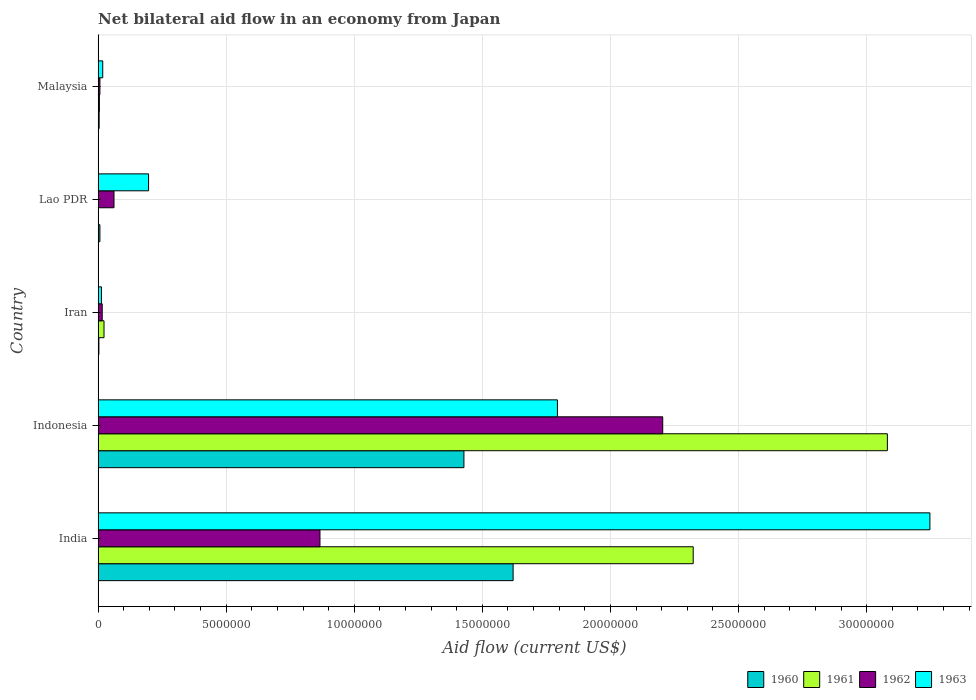Are the number of bars per tick equal to the number of legend labels?
Your answer should be compact. Yes. What is the label of the 5th group of bars from the top?
Your answer should be very brief. India. In how many cases, is the number of bars for a given country not equal to the number of legend labels?
Your answer should be very brief. 0. What is the net bilateral aid flow in 1963 in Lao PDR?
Offer a very short reply. 1.97e+06. Across all countries, what is the maximum net bilateral aid flow in 1963?
Offer a terse response. 3.25e+07. Across all countries, what is the minimum net bilateral aid flow in 1962?
Your answer should be very brief. 7.00e+04. In which country was the net bilateral aid flow in 1961 minimum?
Provide a succinct answer. Lao PDR. What is the total net bilateral aid flow in 1963 in the graph?
Ensure brevity in your answer.  5.27e+07. What is the difference between the net bilateral aid flow in 1961 in Malaysia and the net bilateral aid flow in 1962 in Iran?
Your response must be concise. -1.10e+05. What is the average net bilateral aid flow in 1961 per country?
Keep it short and to the point. 1.09e+07. What is the difference between the net bilateral aid flow in 1962 and net bilateral aid flow in 1961 in Indonesia?
Provide a succinct answer. -8.77e+06. In how many countries, is the net bilateral aid flow in 1961 greater than 5000000 US$?
Give a very brief answer. 2. What is the ratio of the net bilateral aid flow in 1963 in India to that in Indonesia?
Offer a very short reply. 1.81. Is the net bilateral aid flow in 1961 in Iran less than that in Lao PDR?
Provide a succinct answer. No. What is the difference between the highest and the second highest net bilateral aid flow in 1960?
Your answer should be very brief. 1.92e+06. What is the difference between the highest and the lowest net bilateral aid flow in 1961?
Offer a terse response. 3.08e+07. In how many countries, is the net bilateral aid flow in 1962 greater than the average net bilateral aid flow in 1962 taken over all countries?
Offer a terse response. 2. Is the sum of the net bilateral aid flow in 1963 in India and Indonesia greater than the maximum net bilateral aid flow in 1961 across all countries?
Ensure brevity in your answer.  Yes. Is it the case that in every country, the sum of the net bilateral aid flow in 1961 and net bilateral aid flow in 1960 is greater than the sum of net bilateral aid flow in 1962 and net bilateral aid flow in 1963?
Offer a terse response. No. What does the 2nd bar from the top in Malaysia represents?
Your answer should be very brief. 1962. What does the 4th bar from the bottom in Lao PDR represents?
Offer a very short reply. 1963. Is it the case that in every country, the sum of the net bilateral aid flow in 1962 and net bilateral aid flow in 1961 is greater than the net bilateral aid flow in 1963?
Make the answer very short. No. How many bars are there?
Your answer should be very brief. 20. How many countries are there in the graph?
Keep it short and to the point. 5. Are the values on the major ticks of X-axis written in scientific E-notation?
Give a very brief answer. No. How many legend labels are there?
Your answer should be very brief. 4. What is the title of the graph?
Your answer should be compact. Net bilateral aid flow in an economy from Japan. What is the label or title of the Y-axis?
Your answer should be very brief. Country. What is the Aid flow (current US$) of 1960 in India?
Give a very brief answer. 1.62e+07. What is the Aid flow (current US$) of 1961 in India?
Provide a short and direct response. 2.32e+07. What is the Aid flow (current US$) in 1962 in India?
Provide a succinct answer. 8.66e+06. What is the Aid flow (current US$) in 1963 in India?
Make the answer very short. 3.25e+07. What is the Aid flow (current US$) in 1960 in Indonesia?
Make the answer very short. 1.43e+07. What is the Aid flow (current US$) of 1961 in Indonesia?
Make the answer very short. 3.08e+07. What is the Aid flow (current US$) of 1962 in Indonesia?
Provide a short and direct response. 2.20e+07. What is the Aid flow (current US$) in 1963 in Indonesia?
Offer a terse response. 1.79e+07. What is the Aid flow (current US$) of 1960 in Iran?
Make the answer very short. 3.00e+04. What is the Aid flow (current US$) in 1961 in Iran?
Offer a terse response. 2.30e+05. What is the Aid flow (current US$) of 1962 in Iran?
Your response must be concise. 1.60e+05. What is the Aid flow (current US$) in 1960 in Lao PDR?
Provide a succinct answer. 7.00e+04. What is the Aid flow (current US$) in 1961 in Lao PDR?
Your response must be concise. 10000. What is the Aid flow (current US$) in 1962 in Lao PDR?
Offer a very short reply. 6.20e+05. What is the Aid flow (current US$) of 1963 in Lao PDR?
Provide a succinct answer. 1.97e+06. Across all countries, what is the maximum Aid flow (current US$) in 1960?
Your response must be concise. 1.62e+07. Across all countries, what is the maximum Aid flow (current US$) of 1961?
Give a very brief answer. 3.08e+07. Across all countries, what is the maximum Aid flow (current US$) of 1962?
Your answer should be compact. 2.20e+07. Across all countries, what is the maximum Aid flow (current US$) of 1963?
Your response must be concise. 3.25e+07. Across all countries, what is the minimum Aid flow (current US$) of 1960?
Provide a succinct answer. 3.00e+04. Across all countries, what is the minimum Aid flow (current US$) of 1961?
Your answer should be compact. 10000. What is the total Aid flow (current US$) of 1960 in the graph?
Make the answer very short. 3.06e+07. What is the total Aid flow (current US$) in 1961 in the graph?
Make the answer very short. 5.43e+07. What is the total Aid flow (current US$) of 1962 in the graph?
Provide a short and direct response. 3.16e+07. What is the total Aid flow (current US$) in 1963 in the graph?
Give a very brief answer. 5.27e+07. What is the difference between the Aid flow (current US$) in 1960 in India and that in Indonesia?
Provide a succinct answer. 1.92e+06. What is the difference between the Aid flow (current US$) of 1961 in India and that in Indonesia?
Your answer should be very brief. -7.58e+06. What is the difference between the Aid flow (current US$) of 1962 in India and that in Indonesia?
Your answer should be very brief. -1.34e+07. What is the difference between the Aid flow (current US$) of 1963 in India and that in Indonesia?
Make the answer very short. 1.45e+07. What is the difference between the Aid flow (current US$) in 1960 in India and that in Iran?
Ensure brevity in your answer.  1.62e+07. What is the difference between the Aid flow (current US$) of 1961 in India and that in Iran?
Give a very brief answer. 2.30e+07. What is the difference between the Aid flow (current US$) in 1962 in India and that in Iran?
Your answer should be very brief. 8.50e+06. What is the difference between the Aid flow (current US$) of 1963 in India and that in Iran?
Your answer should be very brief. 3.23e+07. What is the difference between the Aid flow (current US$) in 1960 in India and that in Lao PDR?
Offer a very short reply. 1.61e+07. What is the difference between the Aid flow (current US$) of 1961 in India and that in Lao PDR?
Your answer should be very brief. 2.32e+07. What is the difference between the Aid flow (current US$) of 1962 in India and that in Lao PDR?
Your response must be concise. 8.04e+06. What is the difference between the Aid flow (current US$) in 1963 in India and that in Lao PDR?
Your answer should be very brief. 3.05e+07. What is the difference between the Aid flow (current US$) in 1960 in India and that in Malaysia?
Offer a very short reply. 1.62e+07. What is the difference between the Aid flow (current US$) in 1961 in India and that in Malaysia?
Provide a short and direct response. 2.32e+07. What is the difference between the Aid flow (current US$) of 1962 in India and that in Malaysia?
Keep it short and to the point. 8.59e+06. What is the difference between the Aid flow (current US$) of 1963 in India and that in Malaysia?
Your answer should be very brief. 3.23e+07. What is the difference between the Aid flow (current US$) of 1960 in Indonesia and that in Iran?
Keep it short and to the point. 1.42e+07. What is the difference between the Aid flow (current US$) in 1961 in Indonesia and that in Iran?
Offer a terse response. 3.06e+07. What is the difference between the Aid flow (current US$) of 1962 in Indonesia and that in Iran?
Keep it short and to the point. 2.19e+07. What is the difference between the Aid flow (current US$) of 1963 in Indonesia and that in Iran?
Ensure brevity in your answer.  1.78e+07. What is the difference between the Aid flow (current US$) in 1960 in Indonesia and that in Lao PDR?
Provide a succinct answer. 1.42e+07. What is the difference between the Aid flow (current US$) of 1961 in Indonesia and that in Lao PDR?
Give a very brief answer. 3.08e+07. What is the difference between the Aid flow (current US$) of 1962 in Indonesia and that in Lao PDR?
Make the answer very short. 2.14e+07. What is the difference between the Aid flow (current US$) of 1963 in Indonesia and that in Lao PDR?
Provide a succinct answer. 1.60e+07. What is the difference between the Aid flow (current US$) in 1960 in Indonesia and that in Malaysia?
Make the answer very short. 1.42e+07. What is the difference between the Aid flow (current US$) of 1961 in Indonesia and that in Malaysia?
Make the answer very short. 3.08e+07. What is the difference between the Aid flow (current US$) of 1962 in Indonesia and that in Malaysia?
Give a very brief answer. 2.20e+07. What is the difference between the Aid flow (current US$) in 1963 in Indonesia and that in Malaysia?
Provide a short and direct response. 1.78e+07. What is the difference between the Aid flow (current US$) of 1960 in Iran and that in Lao PDR?
Provide a succinct answer. -4.00e+04. What is the difference between the Aid flow (current US$) of 1962 in Iran and that in Lao PDR?
Give a very brief answer. -4.60e+05. What is the difference between the Aid flow (current US$) in 1963 in Iran and that in Lao PDR?
Make the answer very short. -1.84e+06. What is the difference between the Aid flow (current US$) of 1963 in Iran and that in Malaysia?
Keep it short and to the point. -5.00e+04. What is the difference between the Aid flow (current US$) of 1960 in Lao PDR and that in Malaysia?
Ensure brevity in your answer.  3.00e+04. What is the difference between the Aid flow (current US$) in 1963 in Lao PDR and that in Malaysia?
Offer a terse response. 1.79e+06. What is the difference between the Aid flow (current US$) in 1960 in India and the Aid flow (current US$) in 1961 in Indonesia?
Your response must be concise. -1.46e+07. What is the difference between the Aid flow (current US$) in 1960 in India and the Aid flow (current US$) in 1962 in Indonesia?
Your answer should be compact. -5.84e+06. What is the difference between the Aid flow (current US$) in 1960 in India and the Aid flow (current US$) in 1963 in Indonesia?
Your answer should be very brief. -1.73e+06. What is the difference between the Aid flow (current US$) of 1961 in India and the Aid flow (current US$) of 1962 in Indonesia?
Offer a terse response. 1.19e+06. What is the difference between the Aid flow (current US$) of 1961 in India and the Aid flow (current US$) of 1963 in Indonesia?
Make the answer very short. 5.30e+06. What is the difference between the Aid flow (current US$) of 1962 in India and the Aid flow (current US$) of 1963 in Indonesia?
Your response must be concise. -9.27e+06. What is the difference between the Aid flow (current US$) in 1960 in India and the Aid flow (current US$) in 1961 in Iran?
Ensure brevity in your answer.  1.60e+07. What is the difference between the Aid flow (current US$) in 1960 in India and the Aid flow (current US$) in 1962 in Iran?
Ensure brevity in your answer.  1.60e+07. What is the difference between the Aid flow (current US$) of 1960 in India and the Aid flow (current US$) of 1963 in Iran?
Provide a short and direct response. 1.61e+07. What is the difference between the Aid flow (current US$) of 1961 in India and the Aid flow (current US$) of 1962 in Iran?
Offer a very short reply. 2.31e+07. What is the difference between the Aid flow (current US$) in 1961 in India and the Aid flow (current US$) in 1963 in Iran?
Keep it short and to the point. 2.31e+07. What is the difference between the Aid flow (current US$) in 1962 in India and the Aid flow (current US$) in 1963 in Iran?
Give a very brief answer. 8.53e+06. What is the difference between the Aid flow (current US$) of 1960 in India and the Aid flow (current US$) of 1961 in Lao PDR?
Ensure brevity in your answer.  1.62e+07. What is the difference between the Aid flow (current US$) of 1960 in India and the Aid flow (current US$) of 1962 in Lao PDR?
Your response must be concise. 1.56e+07. What is the difference between the Aid flow (current US$) of 1960 in India and the Aid flow (current US$) of 1963 in Lao PDR?
Your response must be concise. 1.42e+07. What is the difference between the Aid flow (current US$) of 1961 in India and the Aid flow (current US$) of 1962 in Lao PDR?
Your answer should be very brief. 2.26e+07. What is the difference between the Aid flow (current US$) in 1961 in India and the Aid flow (current US$) in 1963 in Lao PDR?
Give a very brief answer. 2.13e+07. What is the difference between the Aid flow (current US$) in 1962 in India and the Aid flow (current US$) in 1963 in Lao PDR?
Ensure brevity in your answer.  6.69e+06. What is the difference between the Aid flow (current US$) in 1960 in India and the Aid flow (current US$) in 1961 in Malaysia?
Offer a very short reply. 1.62e+07. What is the difference between the Aid flow (current US$) of 1960 in India and the Aid flow (current US$) of 1962 in Malaysia?
Give a very brief answer. 1.61e+07. What is the difference between the Aid flow (current US$) of 1960 in India and the Aid flow (current US$) of 1963 in Malaysia?
Make the answer very short. 1.60e+07. What is the difference between the Aid flow (current US$) of 1961 in India and the Aid flow (current US$) of 1962 in Malaysia?
Keep it short and to the point. 2.32e+07. What is the difference between the Aid flow (current US$) in 1961 in India and the Aid flow (current US$) in 1963 in Malaysia?
Offer a terse response. 2.30e+07. What is the difference between the Aid flow (current US$) in 1962 in India and the Aid flow (current US$) in 1963 in Malaysia?
Offer a terse response. 8.48e+06. What is the difference between the Aid flow (current US$) in 1960 in Indonesia and the Aid flow (current US$) in 1961 in Iran?
Your response must be concise. 1.40e+07. What is the difference between the Aid flow (current US$) of 1960 in Indonesia and the Aid flow (current US$) of 1962 in Iran?
Provide a succinct answer. 1.41e+07. What is the difference between the Aid flow (current US$) of 1960 in Indonesia and the Aid flow (current US$) of 1963 in Iran?
Your response must be concise. 1.42e+07. What is the difference between the Aid flow (current US$) of 1961 in Indonesia and the Aid flow (current US$) of 1962 in Iran?
Give a very brief answer. 3.06e+07. What is the difference between the Aid flow (current US$) in 1961 in Indonesia and the Aid flow (current US$) in 1963 in Iran?
Ensure brevity in your answer.  3.07e+07. What is the difference between the Aid flow (current US$) in 1962 in Indonesia and the Aid flow (current US$) in 1963 in Iran?
Provide a short and direct response. 2.19e+07. What is the difference between the Aid flow (current US$) in 1960 in Indonesia and the Aid flow (current US$) in 1961 in Lao PDR?
Provide a succinct answer. 1.43e+07. What is the difference between the Aid flow (current US$) in 1960 in Indonesia and the Aid flow (current US$) in 1962 in Lao PDR?
Your answer should be compact. 1.37e+07. What is the difference between the Aid flow (current US$) of 1960 in Indonesia and the Aid flow (current US$) of 1963 in Lao PDR?
Provide a short and direct response. 1.23e+07. What is the difference between the Aid flow (current US$) of 1961 in Indonesia and the Aid flow (current US$) of 1962 in Lao PDR?
Your response must be concise. 3.02e+07. What is the difference between the Aid flow (current US$) in 1961 in Indonesia and the Aid flow (current US$) in 1963 in Lao PDR?
Your answer should be compact. 2.88e+07. What is the difference between the Aid flow (current US$) of 1962 in Indonesia and the Aid flow (current US$) of 1963 in Lao PDR?
Your answer should be very brief. 2.01e+07. What is the difference between the Aid flow (current US$) in 1960 in Indonesia and the Aid flow (current US$) in 1961 in Malaysia?
Offer a very short reply. 1.42e+07. What is the difference between the Aid flow (current US$) in 1960 in Indonesia and the Aid flow (current US$) in 1962 in Malaysia?
Your answer should be very brief. 1.42e+07. What is the difference between the Aid flow (current US$) of 1960 in Indonesia and the Aid flow (current US$) of 1963 in Malaysia?
Provide a short and direct response. 1.41e+07. What is the difference between the Aid flow (current US$) in 1961 in Indonesia and the Aid flow (current US$) in 1962 in Malaysia?
Make the answer very short. 3.07e+07. What is the difference between the Aid flow (current US$) in 1961 in Indonesia and the Aid flow (current US$) in 1963 in Malaysia?
Your answer should be compact. 3.06e+07. What is the difference between the Aid flow (current US$) in 1962 in Indonesia and the Aid flow (current US$) in 1963 in Malaysia?
Your response must be concise. 2.19e+07. What is the difference between the Aid flow (current US$) in 1960 in Iran and the Aid flow (current US$) in 1961 in Lao PDR?
Keep it short and to the point. 2.00e+04. What is the difference between the Aid flow (current US$) in 1960 in Iran and the Aid flow (current US$) in 1962 in Lao PDR?
Provide a short and direct response. -5.90e+05. What is the difference between the Aid flow (current US$) in 1960 in Iran and the Aid flow (current US$) in 1963 in Lao PDR?
Keep it short and to the point. -1.94e+06. What is the difference between the Aid flow (current US$) of 1961 in Iran and the Aid flow (current US$) of 1962 in Lao PDR?
Provide a short and direct response. -3.90e+05. What is the difference between the Aid flow (current US$) in 1961 in Iran and the Aid flow (current US$) in 1963 in Lao PDR?
Provide a succinct answer. -1.74e+06. What is the difference between the Aid flow (current US$) in 1962 in Iran and the Aid flow (current US$) in 1963 in Lao PDR?
Make the answer very short. -1.81e+06. What is the difference between the Aid flow (current US$) of 1960 in Iran and the Aid flow (current US$) of 1961 in Malaysia?
Give a very brief answer. -2.00e+04. What is the difference between the Aid flow (current US$) of 1960 in Iran and the Aid flow (current US$) of 1963 in Malaysia?
Make the answer very short. -1.50e+05. What is the difference between the Aid flow (current US$) in 1961 in Iran and the Aid flow (current US$) in 1962 in Malaysia?
Your answer should be very brief. 1.60e+05. What is the difference between the Aid flow (current US$) of 1961 in Iran and the Aid flow (current US$) of 1963 in Malaysia?
Provide a succinct answer. 5.00e+04. What is the difference between the Aid flow (current US$) of 1960 in Lao PDR and the Aid flow (current US$) of 1961 in Malaysia?
Provide a short and direct response. 2.00e+04. What is the difference between the Aid flow (current US$) of 1960 in Lao PDR and the Aid flow (current US$) of 1962 in Malaysia?
Offer a very short reply. 0. What is the difference between the Aid flow (current US$) of 1960 in Lao PDR and the Aid flow (current US$) of 1963 in Malaysia?
Offer a terse response. -1.10e+05. What is the difference between the Aid flow (current US$) of 1961 in Lao PDR and the Aid flow (current US$) of 1962 in Malaysia?
Your answer should be very brief. -6.00e+04. What is the difference between the Aid flow (current US$) in 1961 in Lao PDR and the Aid flow (current US$) in 1963 in Malaysia?
Ensure brevity in your answer.  -1.70e+05. What is the difference between the Aid flow (current US$) in 1962 in Lao PDR and the Aid flow (current US$) in 1963 in Malaysia?
Ensure brevity in your answer.  4.40e+05. What is the average Aid flow (current US$) of 1960 per country?
Ensure brevity in your answer.  6.12e+06. What is the average Aid flow (current US$) in 1961 per country?
Make the answer very short. 1.09e+07. What is the average Aid flow (current US$) in 1962 per country?
Offer a very short reply. 6.31e+06. What is the average Aid flow (current US$) in 1963 per country?
Provide a succinct answer. 1.05e+07. What is the difference between the Aid flow (current US$) in 1960 and Aid flow (current US$) in 1961 in India?
Make the answer very short. -7.03e+06. What is the difference between the Aid flow (current US$) of 1960 and Aid flow (current US$) of 1962 in India?
Make the answer very short. 7.54e+06. What is the difference between the Aid flow (current US$) in 1960 and Aid flow (current US$) in 1963 in India?
Your response must be concise. -1.63e+07. What is the difference between the Aid flow (current US$) of 1961 and Aid flow (current US$) of 1962 in India?
Ensure brevity in your answer.  1.46e+07. What is the difference between the Aid flow (current US$) of 1961 and Aid flow (current US$) of 1963 in India?
Ensure brevity in your answer.  -9.24e+06. What is the difference between the Aid flow (current US$) of 1962 and Aid flow (current US$) of 1963 in India?
Give a very brief answer. -2.38e+07. What is the difference between the Aid flow (current US$) of 1960 and Aid flow (current US$) of 1961 in Indonesia?
Keep it short and to the point. -1.65e+07. What is the difference between the Aid flow (current US$) of 1960 and Aid flow (current US$) of 1962 in Indonesia?
Offer a terse response. -7.76e+06. What is the difference between the Aid flow (current US$) in 1960 and Aid flow (current US$) in 1963 in Indonesia?
Your answer should be very brief. -3.65e+06. What is the difference between the Aid flow (current US$) in 1961 and Aid flow (current US$) in 1962 in Indonesia?
Keep it short and to the point. 8.77e+06. What is the difference between the Aid flow (current US$) of 1961 and Aid flow (current US$) of 1963 in Indonesia?
Offer a terse response. 1.29e+07. What is the difference between the Aid flow (current US$) of 1962 and Aid flow (current US$) of 1963 in Indonesia?
Your answer should be very brief. 4.11e+06. What is the difference between the Aid flow (current US$) in 1960 and Aid flow (current US$) in 1963 in Iran?
Provide a short and direct response. -1.00e+05. What is the difference between the Aid flow (current US$) of 1961 and Aid flow (current US$) of 1962 in Iran?
Offer a terse response. 7.00e+04. What is the difference between the Aid flow (current US$) in 1961 and Aid flow (current US$) in 1963 in Iran?
Your answer should be compact. 1.00e+05. What is the difference between the Aid flow (current US$) in 1960 and Aid flow (current US$) in 1961 in Lao PDR?
Provide a succinct answer. 6.00e+04. What is the difference between the Aid flow (current US$) of 1960 and Aid flow (current US$) of 1962 in Lao PDR?
Give a very brief answer. -5.50e+05. What is the difference between the Aid flow (current US$) of 1960 and Aid flow (current US$) of 1963 in Lao PDR?
Give a very brief answer. -1.90e+06. What is the difference between the Aid flow (current US$) in 1961 and Aid flow (current US$) in 1962 in Lao PDR?
Your answer should be compact. -6.10e+05. What is the difference between the Aid flow (current US$) in 1961 and Aid flow (current US$) in 1963 in Lao PDR?
Your answer should be compact. -1.96e+06. What is the difference between the Aid flow (current US$) of 1962 and Aid flow (current US$) of 1963 in Lao PDR?
Offer a very short reply. -1.35e+06. What is the difference between the Aid flow (current US$) of 1960 and Aid flow (current US$) of 1961 in Malaysia?
Provide a short and direct response. -10000. What is the difference between the Aid flow (current US$) of 1960 and Aid flow (current US$) of 1962 in Malaysia?
Keep it short and to the point. -3.00e+04. What is the difference between the Aid flow (current US$) in 1961 and Aid flow (current US$) in 1962 in Malaysia?
Offer a terse response. -2.00e+04. What is the difference between the Aid flow (current US$) of 1961 and Aid flow (current US$) of 1963 in Malaysia?
Provide a succinct answer. -1.30e+05. What is the ratio of the Aid flow (current US$) of 1960 in India to that in Indonesia?
Ensure brevity in your answer.  1.13. What is the ratio of the Aid flow (current US$) of 1961 in India to that in Indonesia?
Provide a short and direct response. 0.75. What is the ratio of the Aid flow (current US$) in 1962 in India to that in Indonesia?
Ensure brevity in your answer.  0.39. What is the ratio of the Aid flow (current US$) in 1963 in India to that in Indonesia?
Your answer should be compact. 1.81. What is the ratio of the Aid flow (current US$) of 1960 in India to that in Iran?
Give a very brief answer. 540. What is the ratio of the Aid flow (current US$) in 1961 in India to that in Iran?
Keep it short and to the point. 101. What is the ratio of the Aid flow (current US$) of 1962 in India to that in Iran?
Your answer should be very brief. 54.12. What is the ratio of the Aid flow (current US$) of 1963 in India to that in Iran?
Your answer should be very brief. 249.77. What is the ratio of the Aid flow (current US$) of 1960 in India to that in Lao PDR?
Your answer should be compact. 231.43. What is the ratio of the Aid flow (current US$) in 1961 in India to that in Lao PDR?
Keep it short and to the point. 2323. What is the ratio of the Aid flow (current US$) of 1962 in India to that in Lao PDR?
Your answer should be very brief. 13.97. What is the ratio of the Aid flow (current US$) in 1963 in India to that in Lao PDR?
Provide a succinct answer. 16.48. What is the ratio of the Aid flow (current US$) of 1960 in India to that in Malaysia?
Your answer should be very brief. 405. What is the ratio of the Aid flow (current US$) of 1961 in India to that in Malaysia?
Your answer should be compact. 464.6. What is the ratio of the Aid flow (current US$) in 1962 in India to that in Malaysia?
Provide a short and direct response. 123.71. What is the ratio of the Aid flow (current US$) in 1963 in India to that in Malaysia?
Make the answer very short. 180.39. What is the ratio of the Aid flow (current US$) of 1960 in Indonesia to that in Iran?
Ensure brevity in your answer.  476. What is the ratio of the Aid flow (current US$) of 1961 in Indonesia to that in Iran?
Keep it short and to the point. 133.96. What is the ratio of the Aid flow (current US$) of 1962 in Indonesia to that in Iran?
Your answer should be compact. 137.75. What is the ratio of the Aid flow (current US$) in 1963 in Indonesia to that in Iran?
Provide a short and direct response. 137.92. What is the ratio of the Aid flow (current US$) of 1960 in Indonesia to that in Lao PDR?
Your response must be concise. 204. What is the ratio of the Aid flow (current US$) in 1961 in Indonesia to that in Lao PDR?
Provide a short and direct response. 3081. What is the ratio of the Aid flow (current US$) of 1962 in Indonesia to that in Lao PDR?
Your answer should be very brief. 35.55. What is the ratio of the Aid flow (current US$) in 1963 in Indonesia to that in Lao PDR?
Make the answer very short. 9.1. What is the ratio of the Aid flow (current US$) of 1960 in Indonesia to that in Malaysia?
Provide a succinct answer. 357. What is the ratio of the Aid flow (current US$) in 1961 in Indonesia to that in Malaysia?
Your answer should be very brief. 616.2. What is the ratio of the Aid flow (current US$) of 1962 in Indonesia to that in Malaysia?
Offer a very short reply. 314.86. What is the ratio of the Aid flow (current US$) of 1963 in Indonesia to that in Malaysia?
Your answer should be very brief. 99.61. What is the ratio of the Aid flow (current US$) of 1960 in Iran to that in Lao PDR?
Provide a succinct answer. 0.43. What is the ratio of the Aid flow (current US$) of 1962 in Iran to that in Lao PDR?
Your response must be concise. 0.26. What is the ratio of the Aid flow (current US$) in 1963 in Iran to that in Lao PDR?
Your answer should be compact. 0.07. What is the ratio of the Aid flow (current US$) in 1960 in Iran to that in Malaysia?
Your response must be concise. 0.75. What is the ratio of the Aid flow (current US$) of 1961 in Iran to that in Malaysia?
Provide a succinct answer. 4.6. What is the ratio of the Aid flow (current US$) in 1962 in Iran to that in Malaysia?
Ensure brevity in your answer.  2.29. What is the ratio of the Aid flow (current US$) of 1963 in Iran to that in Malaysia?
Provide a succinct answer. 0.72. What is the ratio of the Aid flow (current US$) in 1961 in Lao PDR to that in Malaysia?
Ensure brevity in your answer.  0.2. What is the ratio of the Aid flow (current US$) in 1962 in Lao PDR to that in Malaysia?
Give a very brief answer. 8.86. What is the ratio of the Aid flow (current US$) in 1963 in Lao PDR to that in Malaysia?
Your response must be concise. 10.94. What is the difference between the highest and the second highest Aid flow (current US$) in 1960?
Offer a terse response. 1.92e+06. What is the difference between the highest and the second highest Aid flow (current US$) in 1961?
Offer a very short reply. 7.58e+06. What is the difference between the highest and the second highest Aid flow (current US$) in 1962?
Your answer should be compact. 1.34e+07. What is the difference between the highest and the second highest Aid flow (current US$) in 1963?
Your response must be concise. 1.45e+07. What is the difference between the highest and the lowest Aid flow (current US$) in 1960?
Make the answer very short. 1.62e+07. What is the difference between the highest and the lowest Aid flow (current US$) of 1961?
Your answer should be compact. 3.08e+07. What is the difference between the highest and the lowest Aid flow (current US$) in 1962?
Offer a terse response. 2.20e+07. What is the difference between the highest and the lowest Aid flow (current US$) in 1963?
Provide a succinct answer. 3.23e+07. 